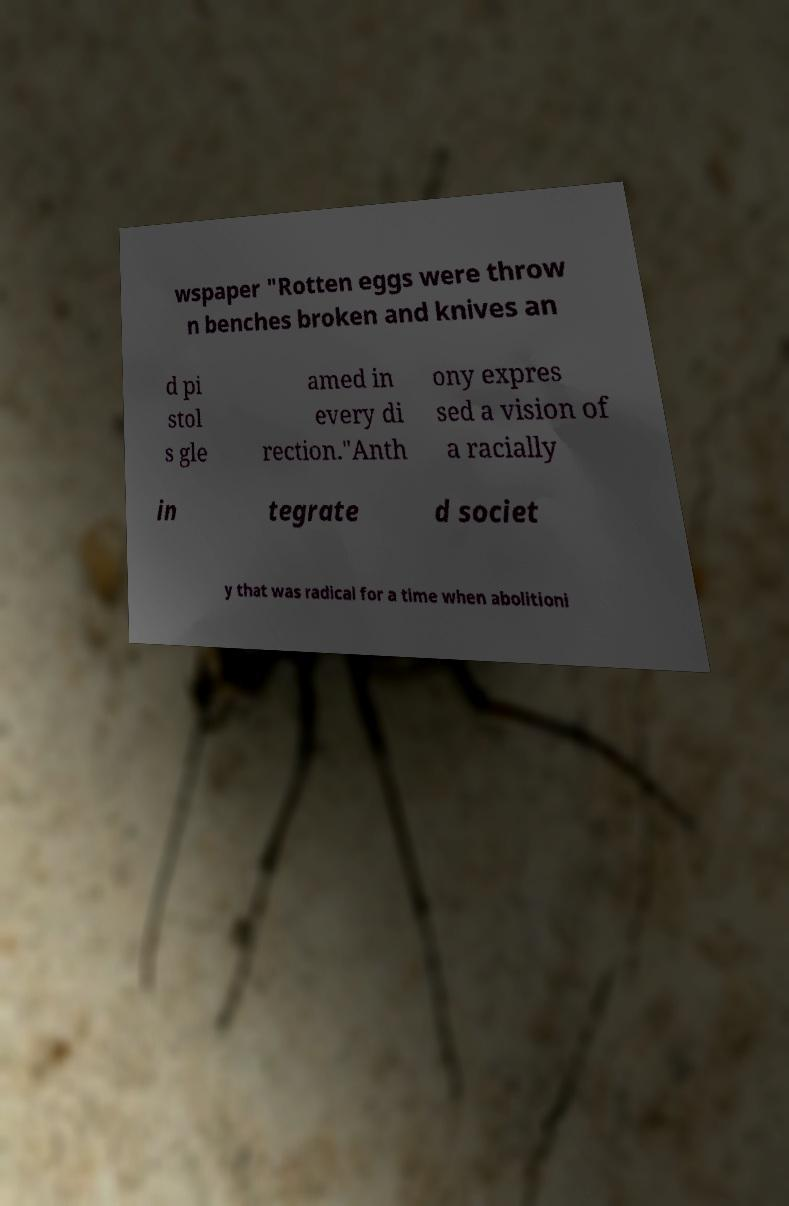For documentation purposes, I need the text within this image transcribed. Could you provide that? wspaper "Rotten eggs were throw n benches broken and knives an d pi stol s gle amed in every di rection."Anth ony expres sed a vision of a racially in tegrate d societ y that was radical for a time when abolitioni 